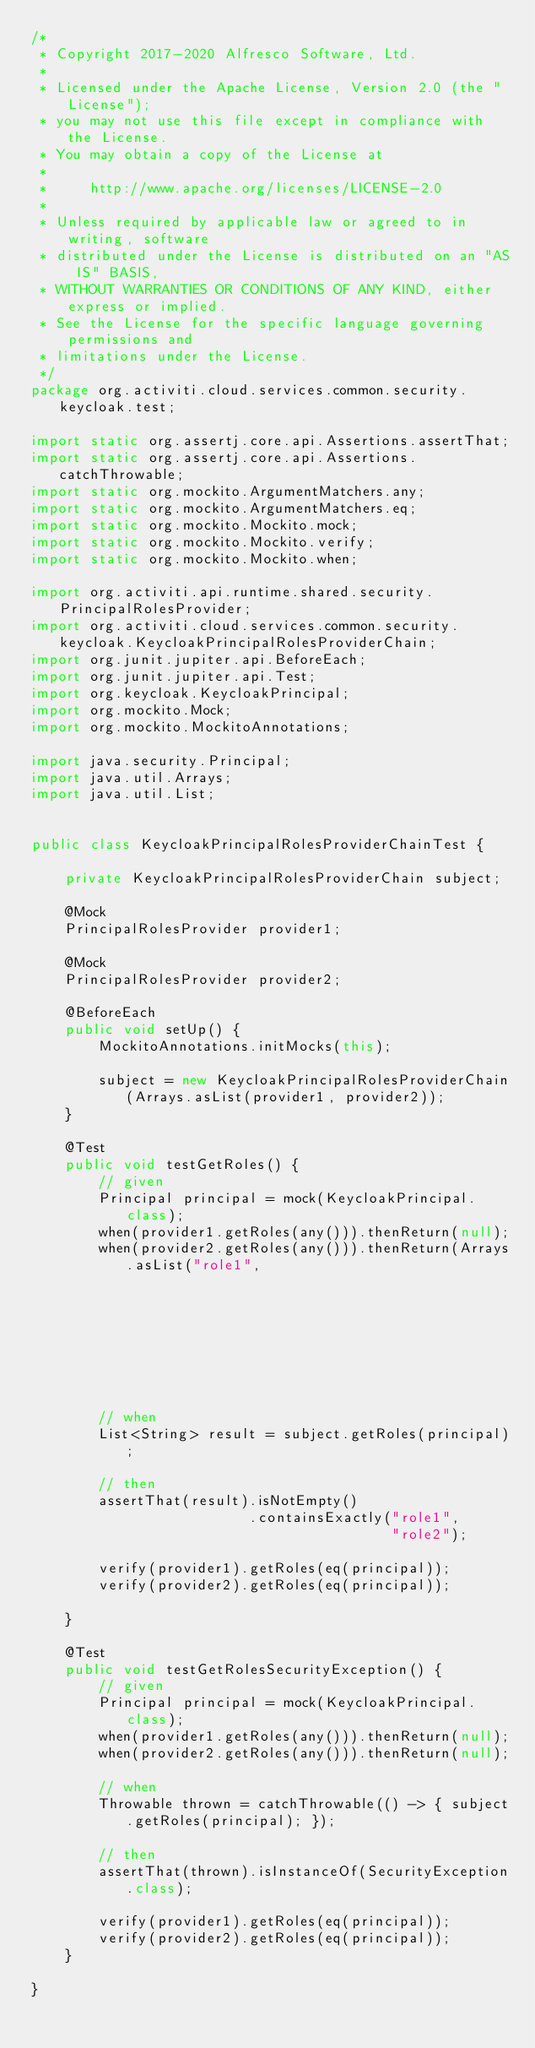<code> <loc_0><loc_0><loc_500><loc_500><_Java_>/*
 * Copyright 2017-2020 Alfresco Software, Ltd.
 *
 * Licensed under the Apache License, Version 2.0 (the "License");
 * you may not use this file except in compliance with the License.
 * You may obtain a copy of the License at
 *
 *     http://www.apache.org/licenses/LICENSE-2.0
 *
 * Unless required by applicable law or agreed to in writing, software
 * distributed under the License is distributed on an "AS IS" BASIS,
 * WITHOUT WARRANTIES OR CONDITIONS OF ANY KIND, either express or implied.
 * See the License for the specific language governing permissions and
 * limitations under the License.
 */
package org.activiti.cloud.services.common.security.keycloak.test;

import static org.assertj.core.api.Assertions.assertThat;
import static org.assertj.core.api.Assertions.catchThrowable;
import static org.mockito.ArgumentMatchers.any;
import static org.mockito.ArgumentMatchers.eq;
import static org.mockito.Mockito.mock;
import static org.mockito.Mockito.verify;
import static org.mockito.Mockito.when;

import org.activiti.api.runtime.shared.security.PrincipalRolesProvider;
import org.activiti.cloud.services.common.security.keycloak.KeycloakPrincipalRolesProviderChain;
import org.junit.jupiter.api.BeforeEach;
import org.junit.jupiter.api.Test;
import org.keycloak.KeycloakPrincipal;
import org.mockito.Mock;
import org.mockito.MockitoAnnotations;

import java.security.Principal;
import java.util.Arrays;
import java.util.List;


public class KeycloakPrincipalRolesProviderChainTest {

    private KeycloakPrincipalRolesProviderChain subject;

    @Mock
    PrincipalRolesProvider provider1;

    @Mock
    PrincipalRolesProvider provider2;

    @BeforeEach
    public void setUp() {
        MockitoAnnotations.initMocks(this);

        subject = new KeycloakPrincipalRolesProviderChain(Arrays.asList(provider1, provider2));
    }

    @Test
    public void testGetRoles() {
        // given
        Principal principal = mock(KeycloakPrincipal.class);
        when(provider1.getRoles(any())).thenReturn(null);
        when(provider2.getRoles(any())).thenReturn(Arrays.asList("role1",
                                                                         "role2"));

        // when
        List<String> result = subject.getRoles(principal);

        // then
        assertThat(result).isNotEmpty()
                          .containsExactly("role1",
                                           "role2");

        verify(provider1).getRoles(eq(principal));
        verify(provider2).getRoles(eq(principal));

    }

    @Test
    public void testGetRolesSecurityException() {
        // given
        Principal principal = mock(KeycloakPrincipal.class);
        when(provider1.getRoles(any())).thenReturn(null);
        when(provider2.getRoles(any())).thenReturn(null);

        // when
        Throwable thrown = catchThrowable(() -> { subject.getRoles(principal); });

        // then
        assertThat(thrown).isInstanceOf(SecurityException.class);

        verify(provider1).getRoles(eq(principal));
        verify(provider2).getRoles(eq(principal));
    }

}
</code> 